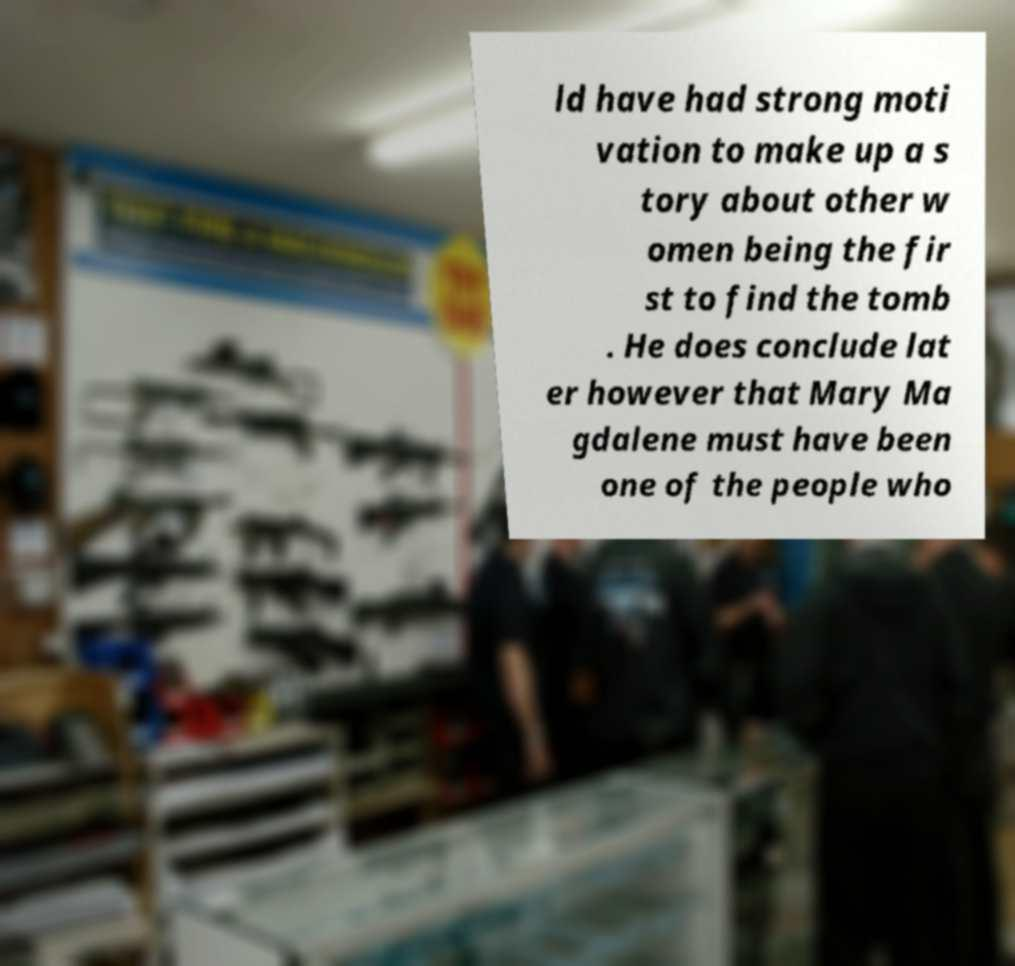Can you read and provide the text displayed in the image?This photo seems to have some interesting text. Can you extract and type it out for me? ld have had strong moti vation to make up a s tory about other w omen being the fir st to find the tomb . He does conclude lat er however that Mary Ma gdalene must have been one of the people who 